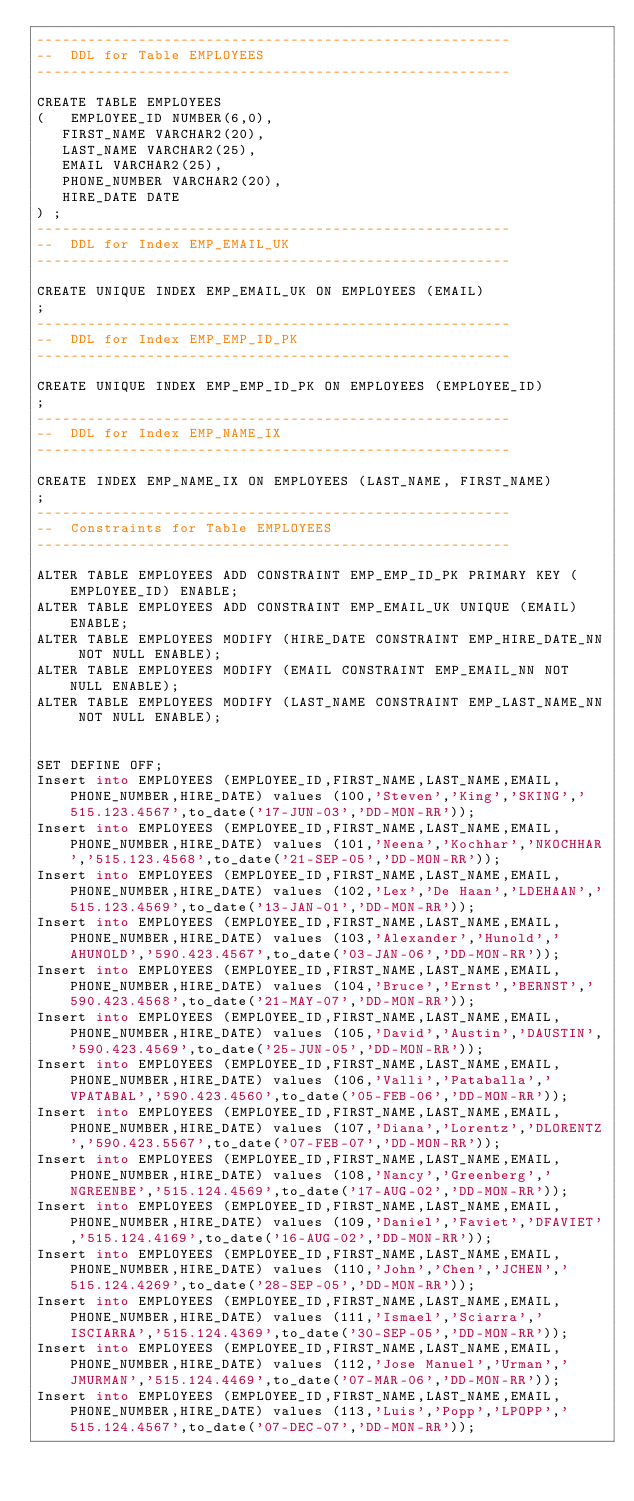Convert code to text. <code><loc_0><loc_0><loc_500><loc_500><_SQL_>--------------------------------------------------------
--  DDL for Table EMPLOYEES
--------------------------------------------------------

CREATE TABLE EMPLOYEES
(	EMPLOYEE_ID NUMBER(6,0),
   FIRST_NAME VARCHAR2(20),
   LAST_NAME VARCHAR2(25),
   EMAIL VARCHAR2(25),
   PHONE_NUMBER VARCHAR2(20),
   HIRE_DATE DATE
) ;
--------------------------------------------------------
--  DDL for Index EMP_EMAIL_UK
--------------------------------------------------------

CREATE UNIQUE INDEX EMP_EMAIL_UK ON EMPLOYEES (EMAIL)
;
--------------------------------------------------------
--  DDL for Index EMP_EMP_ID_PK
--------------------------------------------------------

CREATE UNIQUE INDEX EMP_EMP_ID_PK ON EMPLOYEES (EMPLOYEE_ID)
;
--------------------------------------------------------
--  DDL for Index EMP_NAME_IX
--------------------------------------------------------

CREATE INDEX EMP_NAME_IX ON EMPLOYEES (LAST_NAME, FIRST_NAME)
;
--------------------------------------------------------
--  Constraints for Table EMPLOYEES
--------------------------------------------------------

ALTER TABLE EMPLOYEES ADD CONSTRAINT EMP_EMP_ID_PK PRIMARY KEY (EMPLOYEE_ID) ENABLE;
ALTER TABLE EMPLOYEES ADD CONSTRAINT EMP_EMAIL_UK UNIQUE (EMAIL) ENABLE;
ALTER TABLE EMPLOYEES MODIFY (HIRE_DATE CONSTRAINT EMP_HIRE_DATE_NN NOT NULL ENABLE);
ALTER TABLE EMPLOYEES MODIFY (EMAIL CONSTRAINT EMP_EMAIL_NN NOT NULL ENABLE);
ALTER TABLE EMPLOYEES MODIFY (LAST_NAME CONSTRAINT EMP_LAST_NAME_NN NOT NULL ENABLE);


SET DEFINE OFF;
Insert into EMPLOYEES (EMPLOYEE_ID,FIRST_NAME,LAST_NAME,EMAIL,PHONE_NUMBER,HIRE_DATE) values (100,'Steven','King','SKING','515.123.4567',to_date('17-JUN-03','DD-MON-RR'));
Insert into EMPLOYEES (EMPLOYEE_ID,FIRST_NAME,LAST_NAME,EMAIL,PHONE_NUMBER,HIRE_DATE) values (101,'Neena','Kochhar','NKOCHHAR','515.123.4568',to_date('21-SEP-05','DD-MON-RR'));
Insert into EMPLOYEES (EMPLOYEE_ID,FIRST_NAME,LAST_NAME,EMAIL,PHONE_NUMBER,HIRE_DATE) values (102,'Lex','De Haan','LDEHAAN','515.123.4569',to_date('13-JAN-01','DD-MON-RR'));
Insert into EMPLOYEES (EMPLOYEE_ID,FIRST_NAME,LAST_NAME,EMAIL,PHONE_NUMBER,HIRE_DATE) values (103,'Alexander','Hunold','AHUNOLD','590.423.4567',to_date('03-JAN-06','DD-MON-RR'));
Insert into EMPLOYEES (EMPLOYEE_ID,FIRST_NAME,LAST_NAME,EMAIL,PHONE_NUMBER,HIRE_DATE) values (104,'Bruce','Ernst','BERNST','590.423.4568',to_date('21-MAY-07','DD-MON-RR'));
Insert into EMPLOYEES (EMPLOYEE_ID,FIRST_NAME,LAST_NAME,EMAIL,PHONE_NUMBER,HIRE_DATE) values (105,'David','Austin','DAUSTIN','590.423.4569',to_date('25-JUN-05','DD-MON-RR'));
Insert into EMPLOYEES (EMPLOYEE_ID,FIRST_NAME,LAST_NAME,EMAIL,PHONE_NUMBER,HIRE_DATE) values (106,'Valli','Pataballa','VPATABAL','590.423.4560',to_date('05-FEB-06','DD-MON-RR'));
Insert into EMPLOYEES (EMPLOYEE_ID,FIRST_NAME,LAST_NAME,EMAIL,PHONE_NUMBER,HIRE_DATE) values (107,'Diana','Lorentz','DLORENTZ','590.423.5567',to_date('07-FEB-07','DD-MON-RR'));
Insert into EMPLOYEES (EMPLOYEE_ID,FIRST_NAME,LAST_NAME,EMAIL,PHONE_NUMBER,HIRE_DATE) values (108,'Nancy','Greenberg','NGREENBE','515.124.4569',to_date('17-AUG-02','DD-MON-RR'));
Insert into EMPLOYEES (EMPLOYEE_ID,FIRST_NAME,LAST_NAME,EMAIL,PHONE_NUMBER,HIRE_DATE) values (109,'Daniel','Faviet','DFAVIET','515.124.4169',to_date('16-AUG-02','DD-MON-RR'));
Insert into EMPLOYEES (EMPLOYEE_ID,FIRST_NAME,LAST_NAME,EMAIL,PHONE_NUMBER,HIRE_DATE) values (110,'John','Chen','JCHEN','515.124.4269',to_date('28-SEP-05','DD-MON-RR'));
Insert into EMPLOYEES (EMPLOYEE_ID,FIRST_NAME,LAST_NAME,EMAIL,PHONE_NUMBER,HIRE_DATE) values (111,'Ismael','Sciarra','ISCIARRA','515.124.4369',to_date('30-SEP-05','DD-MON-RR'));
Insert into EMPLOYEES (EMPLOYEE_ID,FIRST_NAME,LAST_NAME,EMAIL,PHONE_NUMBER,HIRE_DATE) values (112,'Jose Manuel','Urman','JMURMAN','515.124.4469',to_date('07-MAR-06','DD-MON-RR'));
Insert into EMPLOYEES (EMPLOYEE_ID,FIRST_NAME,LAST_NAME,EMAIL,PHONE_NUMBER,HIRE_DATE) values (113,'Luis','Popp','LPOPP','515.124.4567',to_date('07-DEC-07','DD-MON-RR'));</code> 